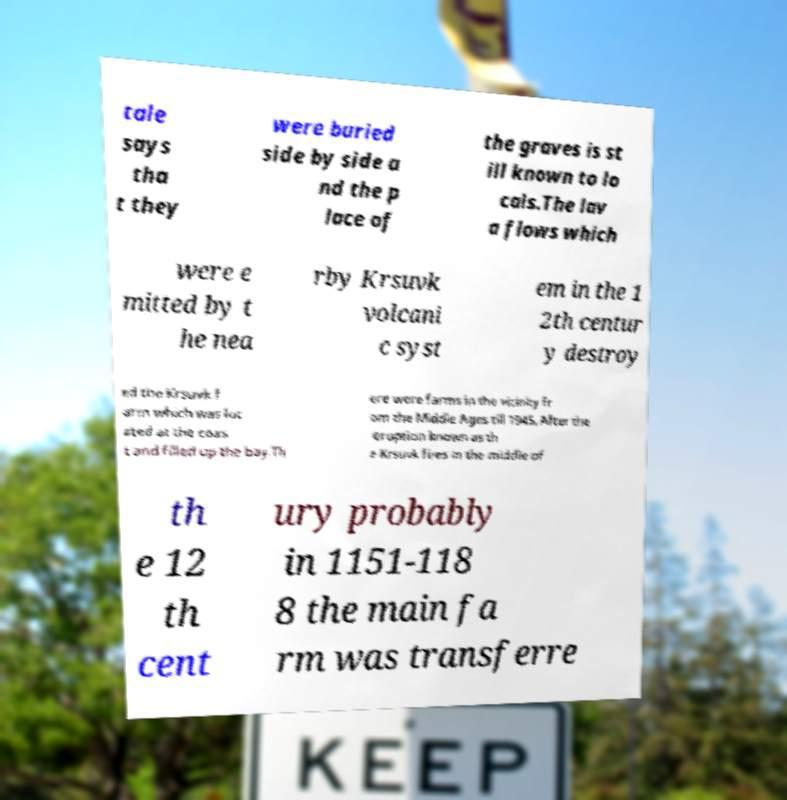Please identify and transcribe the text found in this image. tale says tha t they were buried side by side a nd the p lace of the graves is st ill known to lo cals.The lav a flows which were e mitted by t he nea rby Krsuvk volcani c syst em in the 1 2th centur y destroy ed the Krsuvk f arm which was loc ated at the coas t and filled up the bay.Th ere were farms in the vicinity fr om the Middle Ages till 1945. After the eruption known as th e Krsuvk fires in the middle of th e 12 th cent ury probably in 1151-118 8 the main fa rm was transferre 